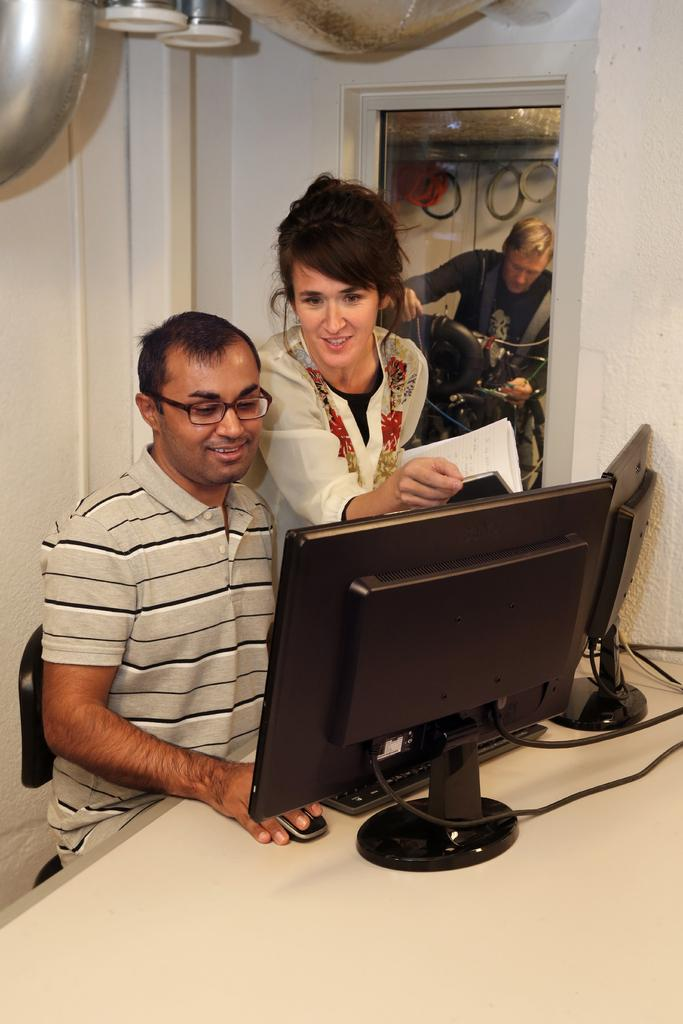Who are the people in the image? There is a man and a woman in the image. Where are they located? They are at a table. What are they doing at the table? They are working on a computer. What can be seen in the background of the image? There is a wall, a door, and a poster in the background of the image. What type of beetle can be seen crawling on the wall in the image? There is no beetle present in the image; the wall is visible in the background, but no insects are mentioned or depicted. 